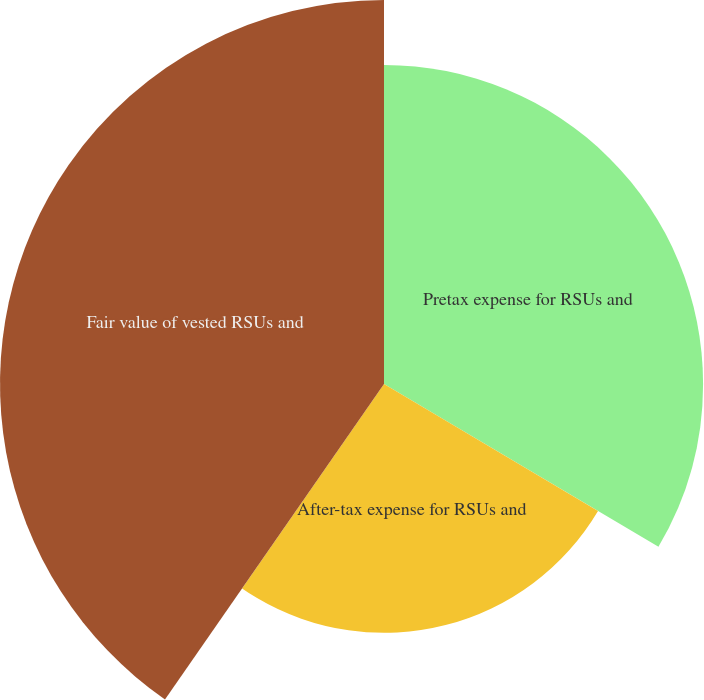<chart> <loc_0><loc_0><loc_500><loc_500><pie_chart><fcel>Pretax expense for RSUs and<fcel>After-tax expense for RSUs and<fcel>Fair value of vested RSUs and<nl><fcel>33.52%<fcel>26.14%<fcel>40.34%<nl></chart> 